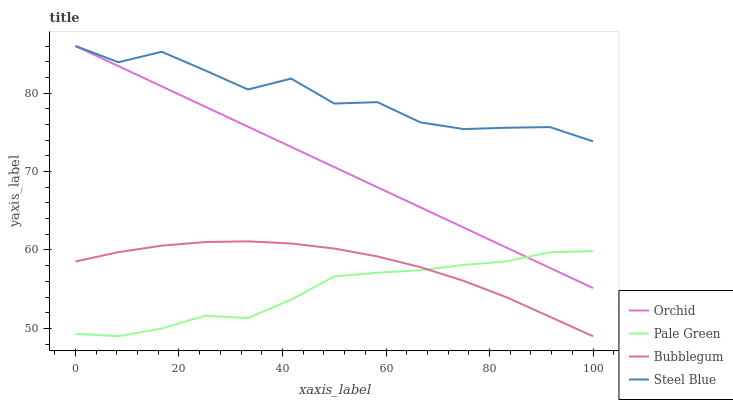Does Bubblegum have the minimum area under the curve?
Answer yes or no. No. Does Bubblegum have the maximum area under the curve?
Answer yes or no. No. Is Bubblegum the smoothest?
Answer yes or no. No. Is Bubblegum the roughest?
Answer yes or no. No. Does Steel Blue have the lowest value?
Answer yes or no. No. Does Bubblegum have the highest value?
Answer yes or no. No. Is Bubblegum less than Orchid?
Answer yes or no. Yes. Is Steel Blue greater than Pale Green?
Answer yes or no. Yes. Does Bubblegum intersect Orchid?
Answer yes or no. No. 